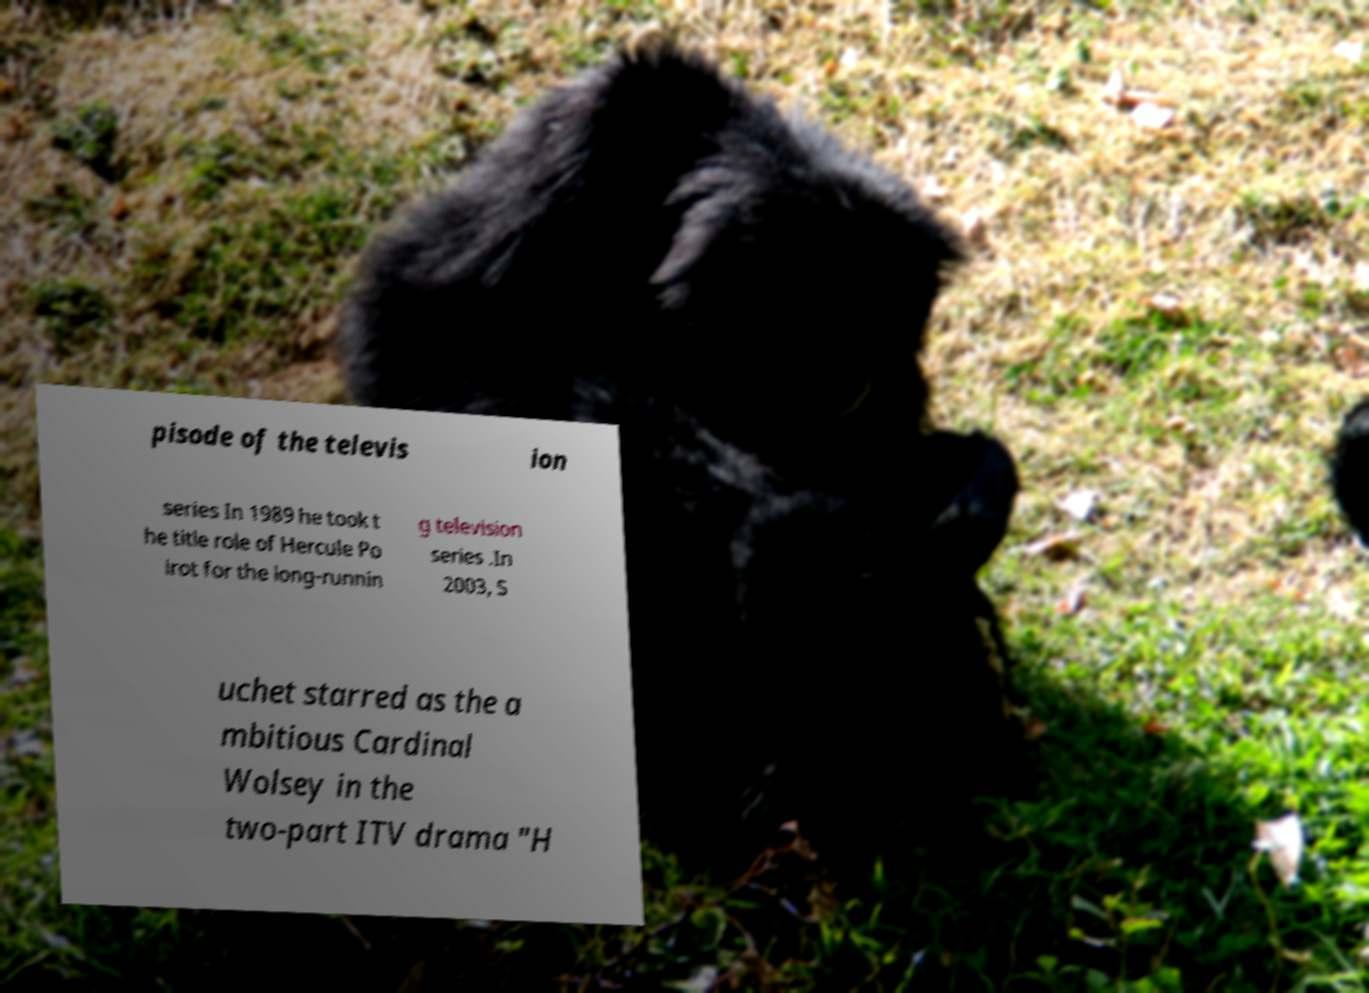What messages or text are displayed in this image? I need them in a readable, typed format. pisode of the televis ion series In 1989 he took t he title role of Hercule Po irot for the long-runnin g television series .In 2003, S uchet starred as the a mbitious Cardinal Wolsey in the two-part ITV drama "H 